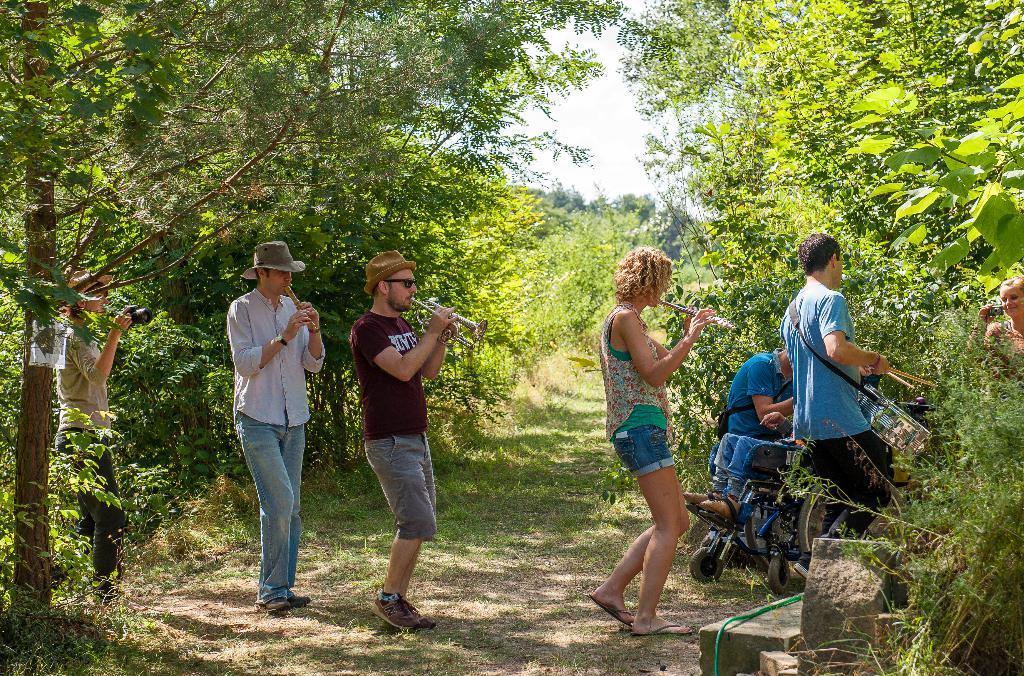Can you describe this image briefly? There are four people playing musical instruments and walking. Here is a person sitting on the wheelchair. I can see two women holding cameras. This looks like a rock. These are the trees with branches and leaves. 